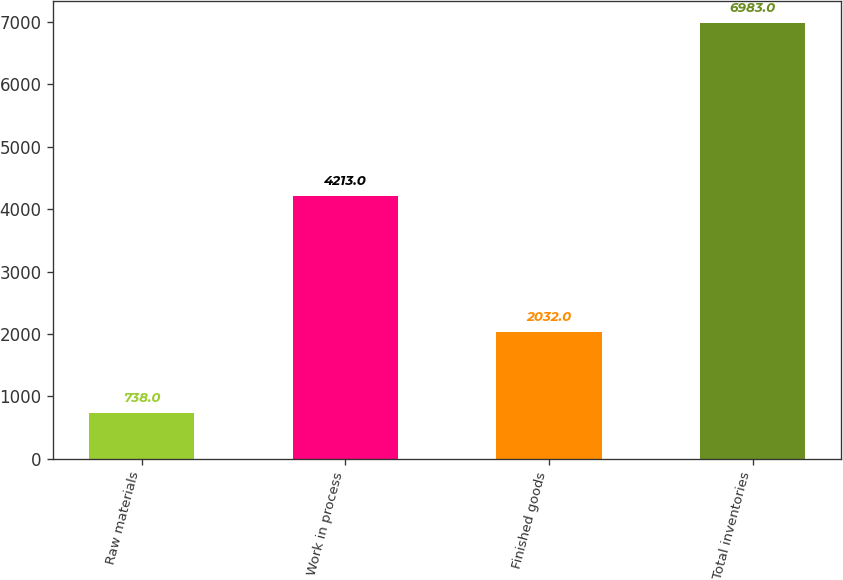<chart> <loc_0><loc_0><loc_500><loc_500><bar_chart><fcel>Raw materials<fcel>Work in process<fcel>Finished goods<fcel>Total inventories<nl><fcel>738<fcel>4213<fcel>2032<fcel>6983<nl></chart> 